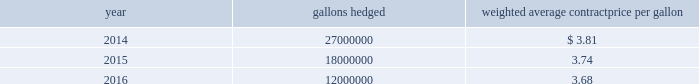Republic services , inc .
Notes to consolidated financial statements 2014 ( continued ) 16 .
Financial instruments fuel hedges we have entered into multiple swap agreements designated as cash flow hedges to mitigate some of our exposure related to changes in diesel fuel prices .
These swaps qualified for , and were designated as , effective hedges of changes in the prices of forecasted diesel fuel purchases ( fuel hedges ) .
The table summarizes our outstanding fuel hedges as of december 31 , 2013 : year gallons hedged weighted average contract price per gallon .
If the national u.s .
On-highway average price for a gallon of diesel fuel as published by the department of energy exceeds the contract price per gallon , we receive the difference between the average price and the contract price ( multiplied by the notional gallons ) from the counterparty .
If the average price is less than the contract price per gallon , we pay the difference to the counterparty .
The fair values of our fuel hedges are determined using standard option valuation models with assumptions about commodity prices being based on those observed in underlying markets ( level 2 in the fair value hierarchy ) .
The aggregate fair values of our outstanding fuel hedges as of december 31 , 2013 and 2012 were current assets of $ 6.7 million and $ 3.1 million , respectively , and current liabilities of $ 0.1 million and $ 0.4 million , respectively , and have been recorded in other prepaid expenses and other current assets and other accrued liabilities in our consolidated balance sheets , respectively .
The ineffective portions of the changes in fair values resulted in ( losses ) gains of less than $ 0.1 million for the years ended december 31 , 2013 , 2012 and 2011 , and have been recorded in other income ( expense ) , net in our consolidated statements of income .
Total gain ( loss ) recognized in other comprehensive income for fuel hedges ( the effective portion ) was $ 2.4 million , $ 3.4 million and $ ( 1.7 ) million , for the years ended december 31 , 2013 , 2012 and 2011 , respectively .
Recycling commodity hedges our revenue from sale of recycling commodities is primarily from sales of old corrugated cardboard ( occ ) and old newspaper ( onp ) .
We use derivative instruments such as swaps and costless collars designated as cash flow hedges to manage our exposure to changes in prices of these commodities .
We have entered into multiple agreements related to the forecasted occ and onp sales .
The agreements qualified for , and were designated as , effective hedges of changes in the prices of certain forecasted recycling commodity sales ( commodity hedges ) .
We entered into costless collar agreements on forecasted sales of occ and onp .
The agreements involve combining a purchased put option giving us the right to sell occ and onp at an established floor strike price with a written call option obligating us to deliver occ and onp at an established cap strike price .
The puts and calls have the same settlement dates , are net settled in cash on such dates and have the same terms to expiration .
The contemporaneous combination of options resulted in no net premium for us and represent costless collars .
Under these agreements , we will make or receive no payments as long as the settlement price is between the floor price and cap price ; however , if the settlement price is above the cap , we will pay the counterparty an amount equal to the excess of the settlement price over the cap times the monthly volumes hedged .
If the settlement price .
What was the ratio of the gallons hedged in 2014 to 2016? 
Rationale: the ratio of the gallons hedged in 2014 to 2016 was 2.25
Computations: (27000000 / 12000000)
Answer: 2.25. Republic services , inc .
Notes to consolidated financial statements 2014 ( continued ) 16 .
Financial instruments fuel hedges we have entered into multiple swap agreements designated as cash flow hedges to mitigate some of our exposure related to changes in diesel fuel prices .
These swaps qualified for , and were designated as , effective hedges of changes in the prices of forecasted diesel fuel purchases ( fuel hedges ) .
The table summarizes our outstanding fuel hedges as of december 31 , 2013 : year gallons hedged weighted average contract price per gallon .
If the national u.s .
On-highway average price for a gallon of diesel fuel as published by the department of energy exceeds the contract price per gallon , we receive the difference between the average price and the contract price ( multiplied by the notional gallons ) from the counterparty .
If the average price is less than the contract price per gallon , we pay the difference to the counterparty .
The fair values of our fuel hedges are determined using standard option valuation models with assumptions about commodity prices being based on those observed in underlying markets ( level 2 in the fair value hierarchy ) .
The aggregate fair values of our outstanding fuel hedges as of december 31 , 2013 and 2012 were current assets of $ 6.7 million and $ 3.1 million , respectively , and current liabilities of $ 0.1 million and $ 0.4 million , respectively , and have been recorded in other prepaid expenses and other current assets and other accrued liabilities in our consolidated balance sheets , respectively .
The ineffective portions of the changes in fair values resulted in ( losses ) gains of less than $ 0.1 million for the years ended december 31 , 2013 , 2012 and 2011 , and have been recorded in other income ( expense ) , net in our consolidated statements of income .
Total gain ( loss ) recognized in other comprehensive income for fuel hedges ( the effective portion ) was $ 2.4 million , $ 3.4 million and $ ( 1.7 ) million , for the years ended december 31 , 2013 , 2012 and 2011 , respectively .
Recycling commodity hedges our revenue from sale of recycling commodities is primarily from sales of old corrugated cardboard ( occ ) and old newspaper ( onp ) .
We use derivative instruments such as swaps and costless collars designated as cash flow hedges to manage our exposure to changes in prices of these commodities .
We have entered into multiple agreements related to the forecasted occ and onp sales .
The agreements qualified for , and were designated as , effective hedges of changes in the prices of certain forecasted recycling commodity sales ( commodity hedges ) .
We entered into costless collar agreements on forecasted sales of occ and onp .
The agreements involve combining a purchased put option giving us the right to sell occ and onp at an established floor strike price with a written call option obligating us to deliver occ and onp at an established cap strike price .
The puts and calls have the same settlement dates , are net settled in cash on such dates and have the same terms to expiration .
The contemporaneous combination of options resulted in no net premium for us and represent costless collars .
Under these agreements , we will make or receive no payments as long as the settlement price is between the floor price and cap price ; however , if the settlement price is above the cap , we will pay the counterparty an amount equal to the excess of the settlement price over the cap times the monthly volumes hedged .
If the settlement price .
What was the growth percent of the total gain ( loss ) recognized in other comprehensive income for fuel hedges from 2012 to 2013? 
Rationale: the percent of the decline from 2012 to 2013 was
Computations: ((2.4 - 3.4) / 3.4)
Answer: -0.29412. 